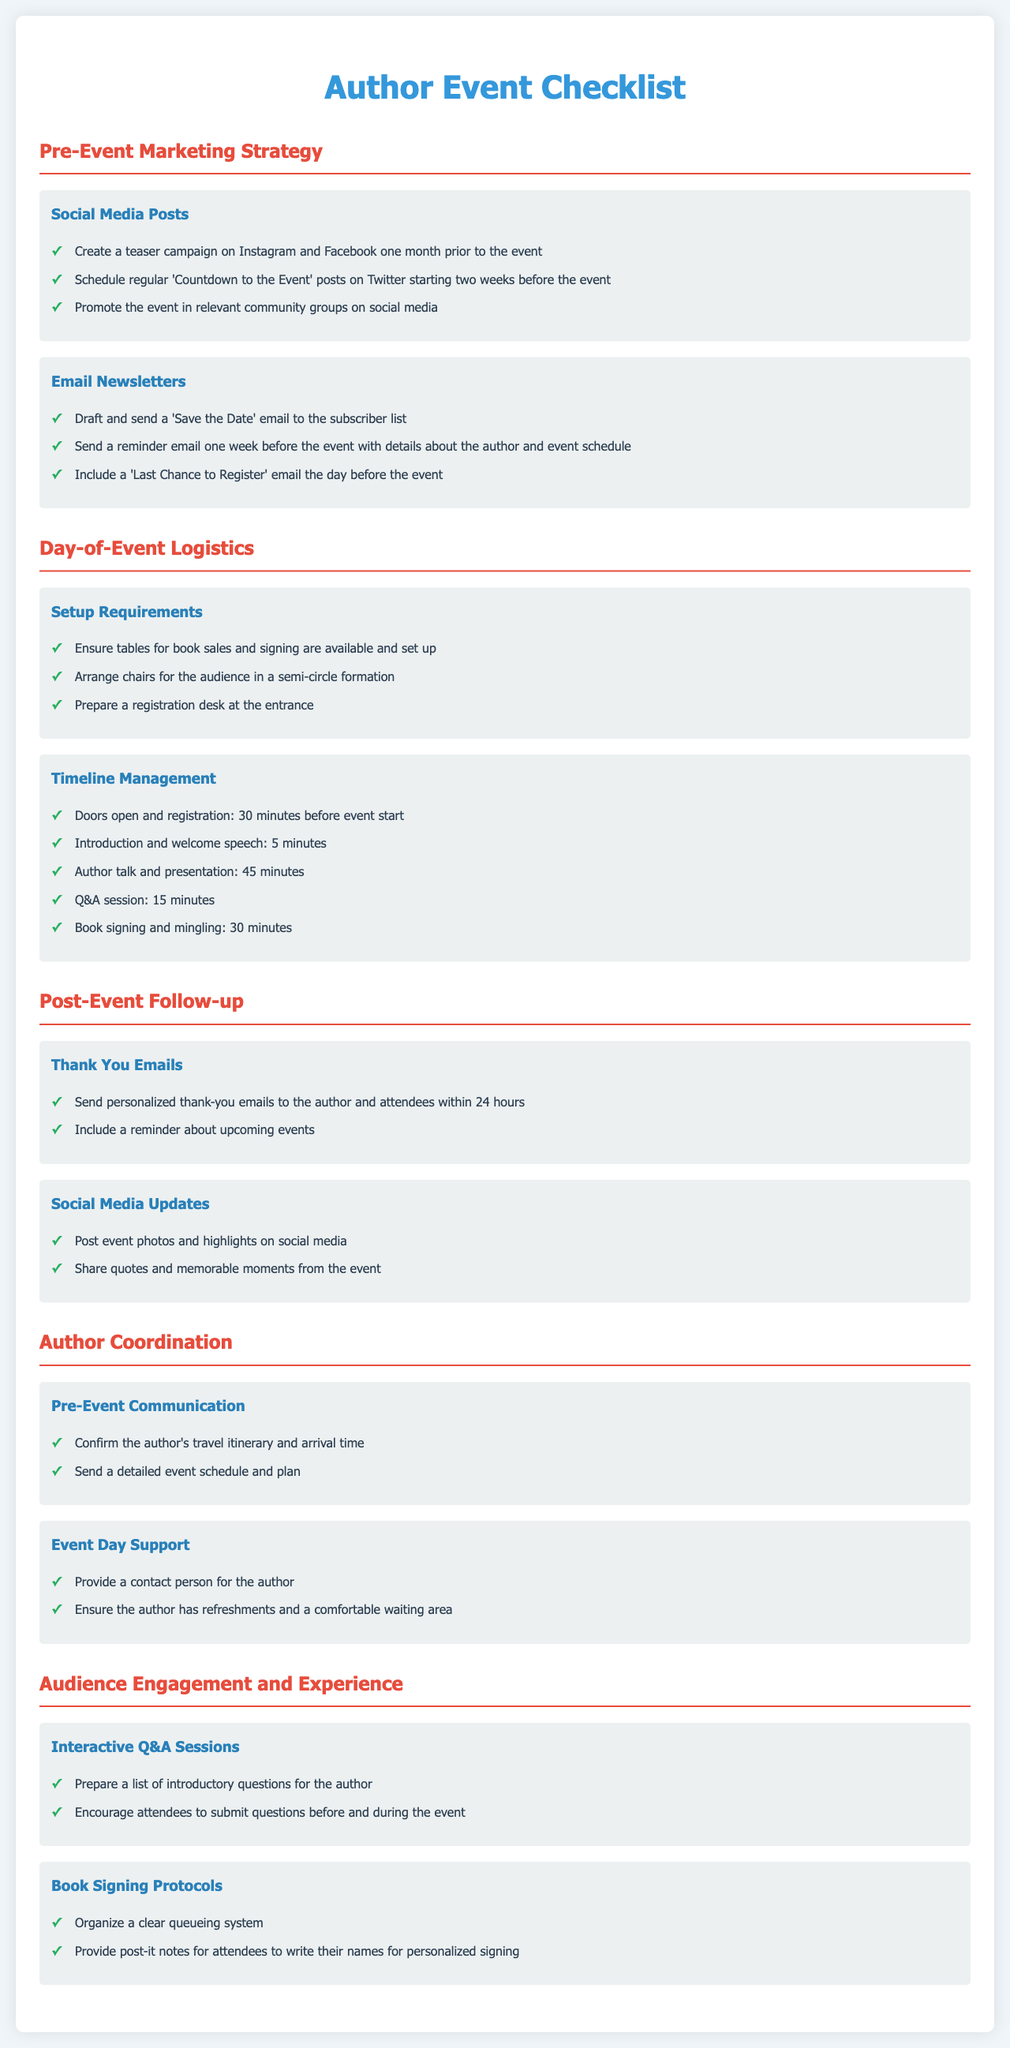what is the main title of the document? The main title is found at the top of the document, indicating the overall subject.
Answer: Author Event Checklist how many sections are in the document? The number of sections can be counted from the headings provided in the checklist.
Answer: 5 what is one of the tasks for the Social Media Posts? This refers to specific examples given under the Social Media Posts section.
Answer: Create a teaser campaign on Instagram and Facebook one month prior to the event what is the duration of the author talk and presentation? This information is derived from the timeline management section of the document.
Answer: 45 minutes which checklist section includes Thank You Emails? This involves understanding the organization of the document and identifying where specific tasks are listed.
Answer: Post-Event Follow-up how many interactive Q&A session tasks are listed? This question requires counting the unique tasks provided under the Audience Engagement and Experience section.
Answer: 2 what is the arrangement style for audience seating mentioned in the Setup Requirements? This refers to how the seating is organized as specified in the day-of-event logistics.
Answer: semi-circle formation what is the checklist group under Author Coordination that refers to event day assistance? This requires identifying the specific group related to support during the event.
Answer: Event Day Support 